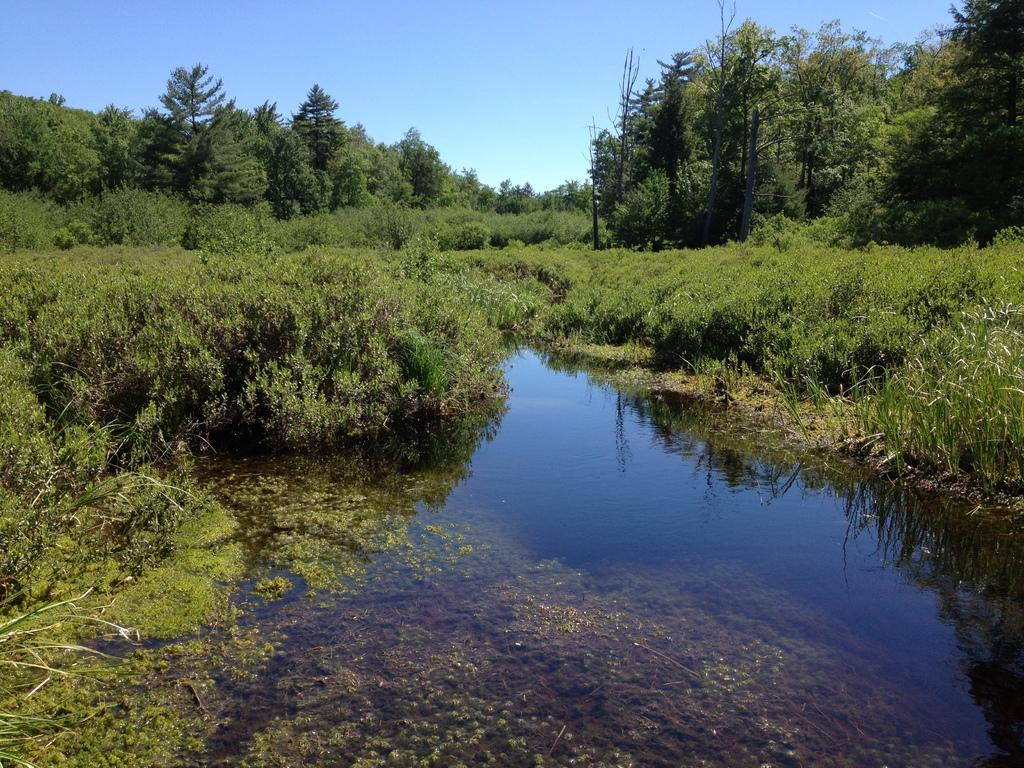What is one of the natural elements visible in the image? Water is visible in the image. What type of vegetation can be seen in the image? Plants, trees, and grass are visible in the image. What part of the natural environment is visible in the image? The sky is visible in the image. Can you see any mountains in the image? There are no mountains visible in the image. What type of amusement park can be seen in the image? There is no amusement park present in the image. 